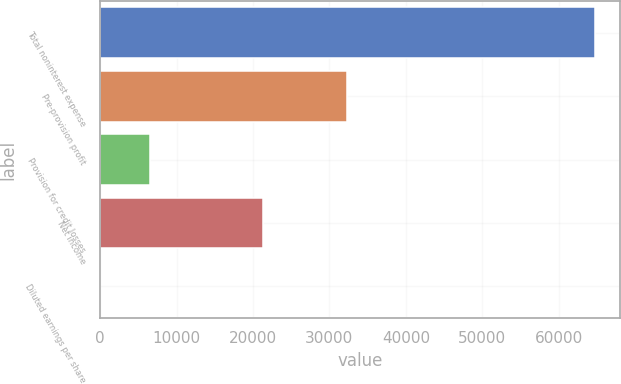<chart> <loc_0><loc_0><loc_500><loc_500><bar_chart><fcel>Total noninterest expense<fcel>Pre-provision profit<fcel>Provision for credit losses<fcel>Net income<fcel>Diluted earnings per share<nl><fcel>64729<fcel>32302<fcel>6477.58<fcel>21284<fcel>5.2<nl></chart> 